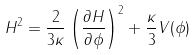Convert formula to latex. <formula><loc_0><loc_0><loc_500><loc_500>H ^ { 2 } = \frac { 2 } { 3 \kappa } \left ( \frac { \partial H } { \partial \phi } \right ) ^ { 2 } + \frac { \kappa } { 3 } V ( \phi )</formula> 